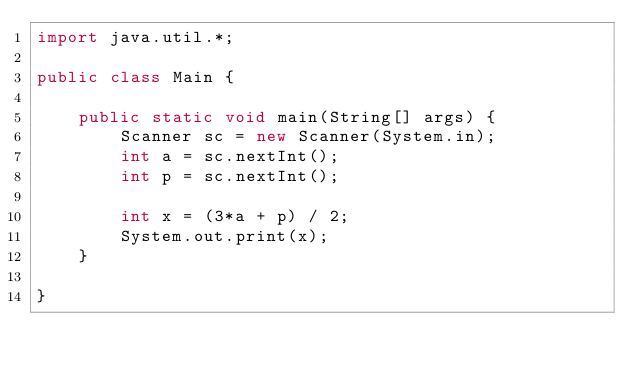Convert code to text. <code><loc_0><loc_0><loc_500><loc_500><_Java_>import java.util.*;

public class Main {

    public static void main(String[] args) {
        Scanner sc = new Scanner(System.in);
        int a = sc.nextInt();
        int p = sc.nextInt();

        int x = (3*a + p) / 2;
        System.out.print(x);
    }

}</code> 